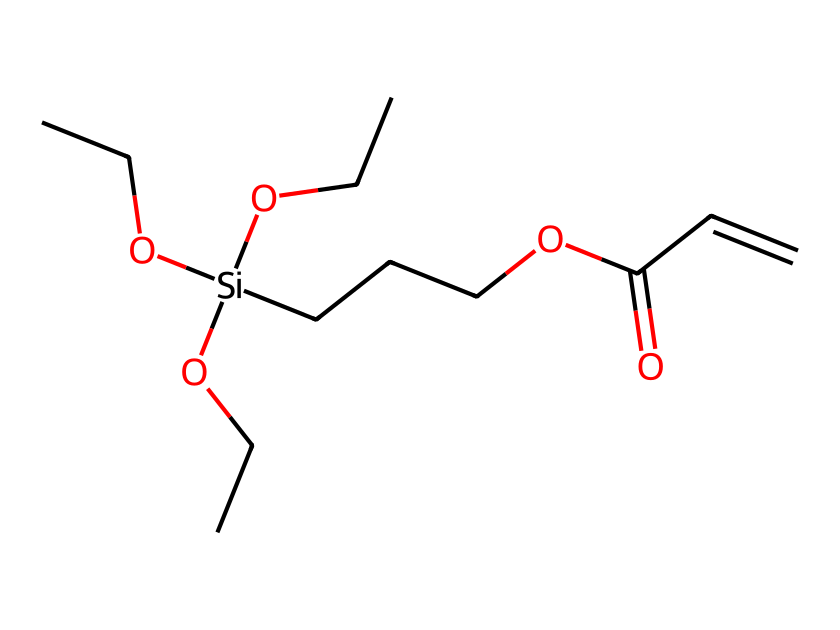What is the total number of carbon atoms in this silane compound? To determine the total number of carbon atoms, we count all the carbon symbols (C) in the SMILES representation. There are 7 carbon atoms represented in the structure.
Answer: 7 How many oxygen atoms are present in the chemical structure? We can count the number of oxygen symbols (O) in the SMILES. There are 3 oxygen atoms present in the chemical.
Answer: 3 What functional group is indicated by the presence of 'C=C' in the structure? The 'C=C' notation represents a double bond between two carbon atoms, indicating that this compound has an alkene functional group.
Answer: alkene What is the degree of substitution of the silicon atom? The silicon (Si) atom is bonded to 3 ethyl groups and one additional chain, totaling 4 substituents. This indicates that the silicon atom has a tetrahedral geometry with four substituents.
Answer: 4 What type of compound does this silane represent when used in tennis shoe soles? This silane is used to create a polymer compound, which offers enhanced durability and flexibility, essential for sports footwear.
Answer: polymer What is the significance of the ester group represented in the formula? The ester group (indicated by 'OC(=O)') suggests that this silane compound may provide properties like flexibility and potentially reduced friction, important for high-performance sports shoes.
Answer: flexibility How does the structure's branching affect its material properties? The branching from the silicon atom allows for a more complex molecular architecture, contributing to improved impact resistance and elasticity, which are desirable in athletic footwear.
Answer: impact resistance and elasticity 